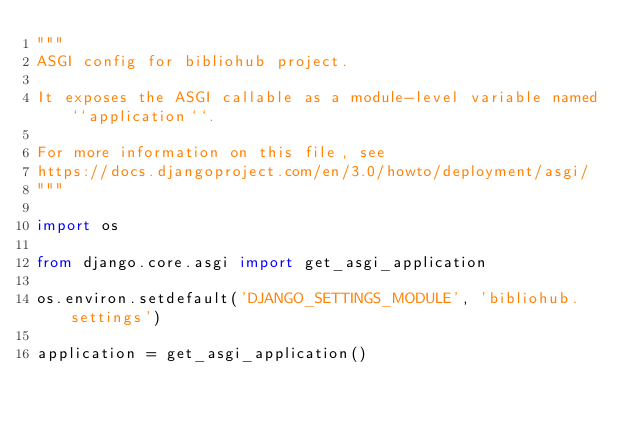Convert code to text. <code><loc_0><loc_0><loc_500><loc_500><_Python_>"""
ASGI config for bibliohub project.

It exposes the ASGI callable as a module-level variable named ``application``.

For more information on this file, see
https://docs.djangoproject.com/en/3.0/howto/deployment/asgi/
"""

import os

from django.core.asgi import get_asgi_application

os.environ.setdefault('DJANGO_SETTINGS_MODULE', 'bibliohub.settings')

application = get_asgi_application()
</code> 